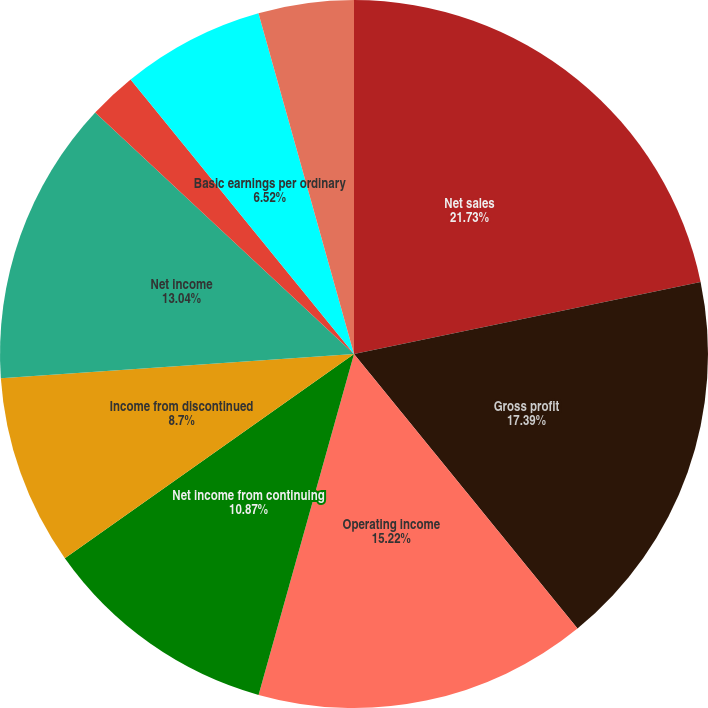Convert chart. <chart><loc_0><loc_0><loc_500><loc_500><pie_chart><fcel>Net sales<fcel>Gross profit<fcel>Operating income<fcel>Net income from continuing<fcel>Income from discontinued<fcel>Net income<fcel>Continuing operations<fcel>Discontinued operations<fcel>Basic earnings per ordinary<fcel>Diluted earnings per ordinary<nl><fcel>21.74%<fcel>17.39%<fcel>15.22%<fcel>10.87%<fcel>8.7%<fcel>13.04%<fcel>2.18%<fcel>0.0%<fcel>6.52%<fcel>4.35%<nl></chart> 